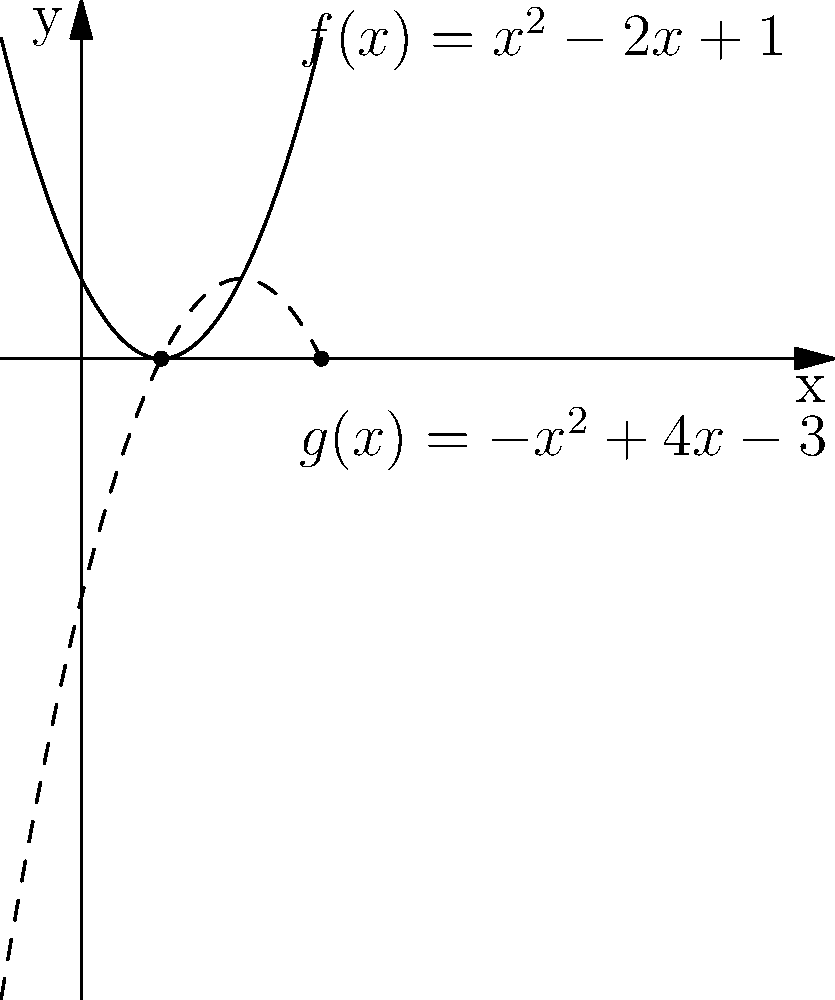In the graph above, two polynomial curves intersect, representing the convergence of two philosophical ideas. The solid curve, $f(x) = x^2 - 2x + 1$, represents a traditional philosophical concept, while the dashed curve, $g(x) = -x^2 + 4x - 3$, represents a more progressive idea. At what x-coordinate do these ideas find common ground, symbolizing the point where these philosophical perspectives align? To find the point where the two philosophical ideas converge, we need to determine where the two polynomial functions intersect. This can be done by setting the equations equal to each other and solving for x.

1) Set the equations equal:
   $x^2 - 2x + 1 = -x^2 + 4x - 3$

2) Rearrange the equation:
   $2x^2 - 6x + 4 = 0$

3) This is a quadratic equation. We can solve it using the quadratic formula:
   $x = \frac{-b \pm \sqrt{b^2 - 4ac}}{2a}$

   Where $a = 2$, $b = -6$, and $c = 4$

4) Substituting these values:
   $x = \frac{6 \pm \sqrt{36 - 32}}{4} = \frac{6 \pm \sqrt{4}}{4} = \frac{6 \pm 2}{4}$

5) This gives us two solutions:
   $x = \frac{6 + 2}{4} = 2$ or $x = \frac{6 - 2}{4} = 1$

6) Looking at the graph, we can see that the curves intersect at $x = 1$ and $x = 3$.

Therefore, the philosophical ideas converge at $x = 1$ and $x = 3$, but the question asks for the first point of intersection, which is at $x = 1$.
Answer: 1 